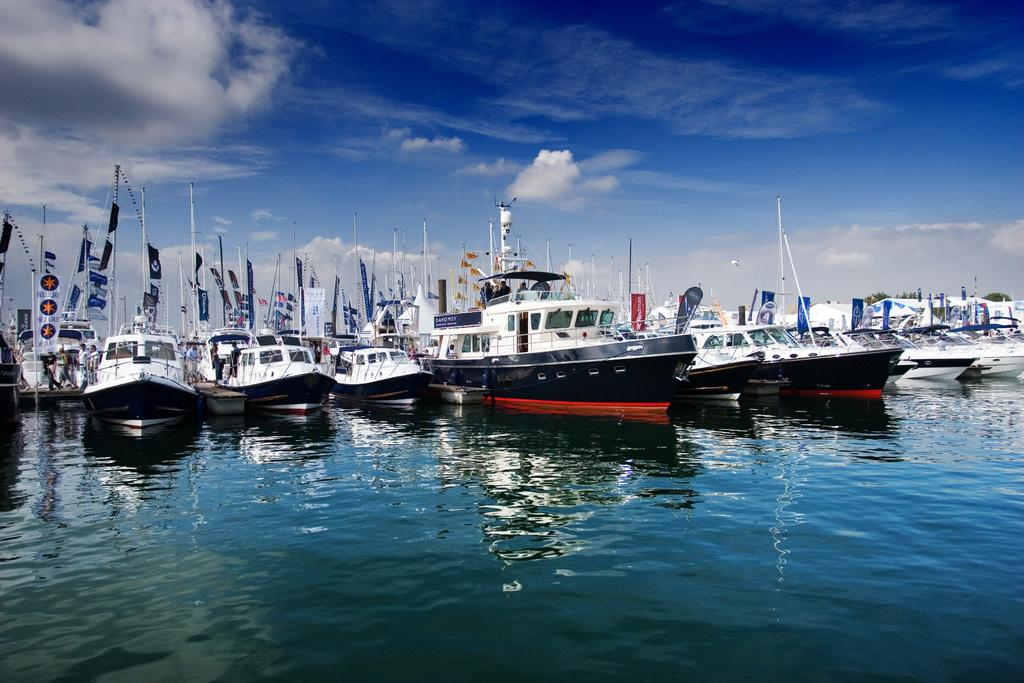What type of vehicles are in the image? There are boats in the image. Where are the boats located? The boats are on the water. What else can be seen in the background of the image? The sky is visible in the background of the image. What type of fowl can be seen flying over the boats in the image? There is no fowl visible in the image; it only features boats on the water and the sky in the background. 